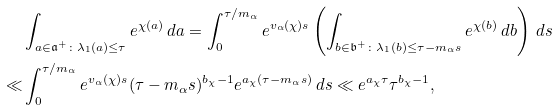Convert formula to latex. <formula><loc_0><loc_0><loc_500><loc_500>& \int _ { a \in \mathfrak { a } ^ { + } \colon \lambda _ { 1 } ( a ) \leq \tau } e ^ { \chi ( a ) } \, d a = \int _ { 0 } ^ { \tau / m _ { \alpha } } e ^ { v _ { \alpha } ( \chi ) s } \left ( \int _ { b \in \mathfrak { b } ^ { + } \colon \lambda _ { 1 } ( b ) \leq \tau - m _ { \alpha } s } e ^ { \chi ( b ) } \, d b \right ) \, d s \\ \ll & \int _ { 0 } ^ { \tau / m _ { \alpha } } e ^ { v _ { \alpha } ( \chi ) s } ( \tau - m _ { \alpha } s ) ^ { b _ { \chi } - 1 } e ^ { a _ { \chi } ( \tau - m _ { \alpha } s ) } \, d s \ll e ^ { a _ { \chi } \tau } \tau ^ { b _ { \chi } - 1 } ,</formula> 